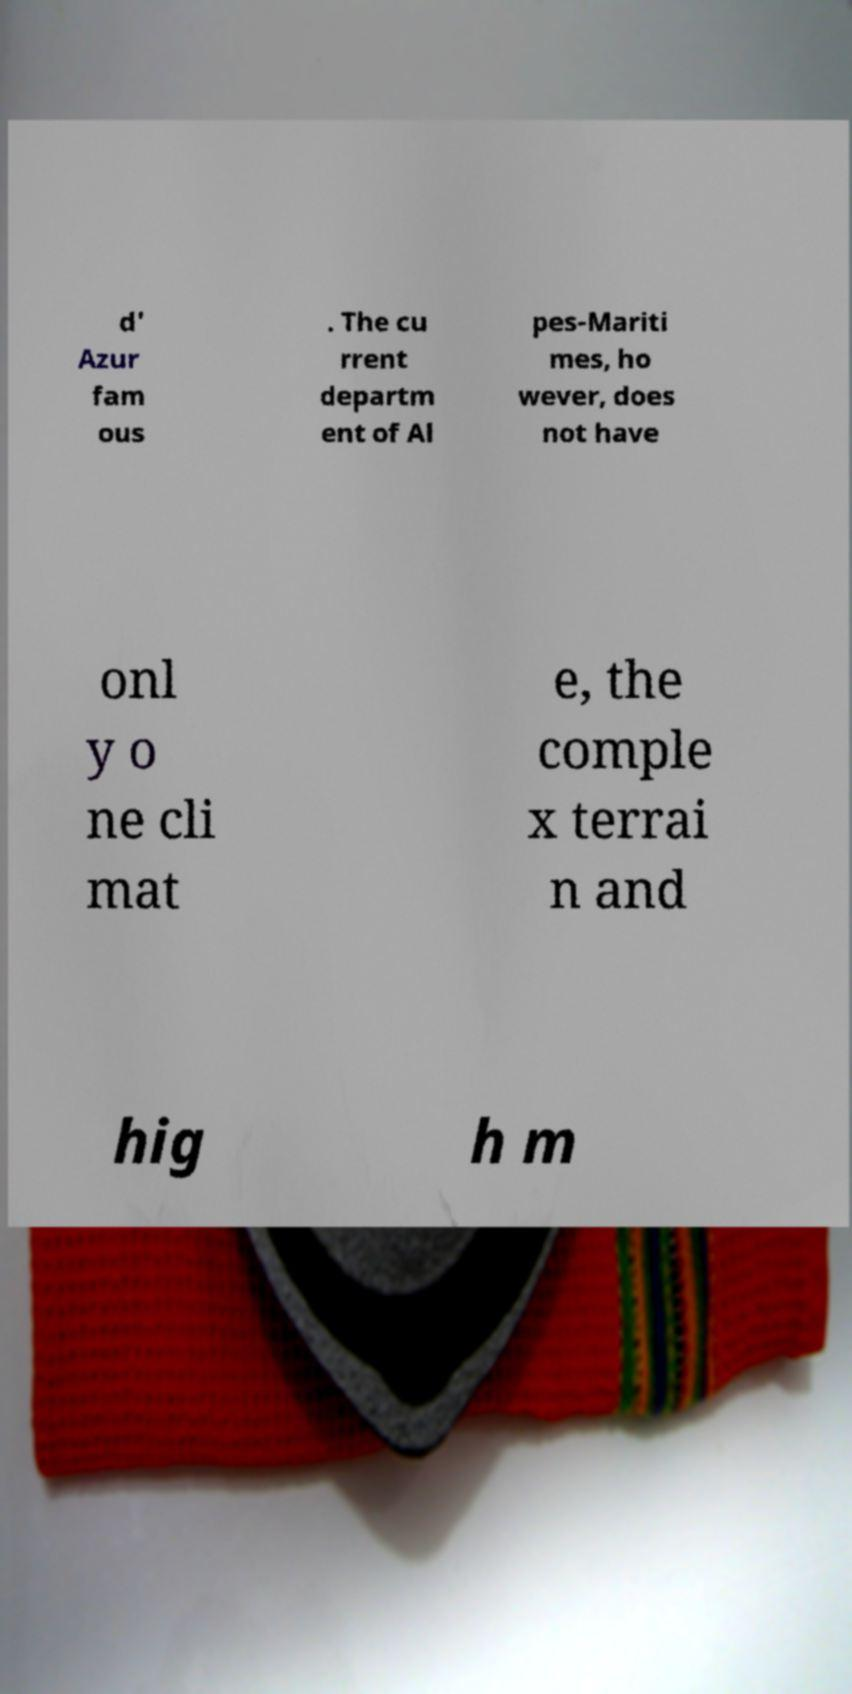For documentation purposes, I need the text within this image transcribed. Could you provide that? d' Azur fam ous . The cu rrent departm ent of Al pes-Mariti mes, ho wever, does not have onl y o ne cli mat e, the comple x terrai n and hig h m 